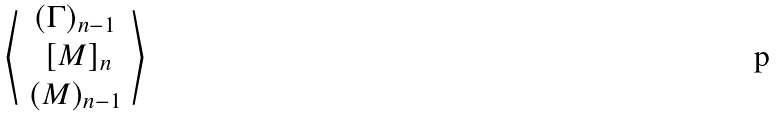Convert formula to latex. <formula><loc_0><loc_0><loc_500><loc_500>\left \langle \begin{array} { c c c } ( \Gamma ) _ { n - 1 } \\ \ [ M ] _ { n } \\ ( M ) _ { n - 1 } \end{array} \right \rangle</formula> 